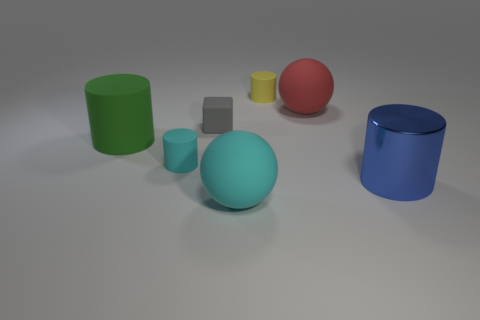Are there more big red matte spheres on the right side of the yellow object than large green matte objects that are behind the large red thing?
Offer a terse response. Yes. Does the tiny object behind the big red object have the same color as the rubber cube?
Keep it short and to the point. No. Is there any other thing that is the same color as the large metal cylinder?
Give a very brief answer. No. Are there more tiny cylinders in front of the large green rubber cylinder than cyan matte cubes?
Provide a short and direct response. Yes. Is the size of the cyan rubber cylinder the same as the yellow matte thing?
Offer a terse response. Yes. What material is the big blue object that is the same shape as the large green matte object?
Make the answer very short. Metal. Is there any other thing that has the same material as the large blue thing?
Make the answer very short. No. How many brown objects are tiny blocks or matte objects?
Provide a short and direct response. 0. There is a large cylinder right of the green thing; what is its material?
Provide a short and direct response. Metal. Is the number of big brown blocks greater than the number of metallic objects?
Make the answer very short. No. 